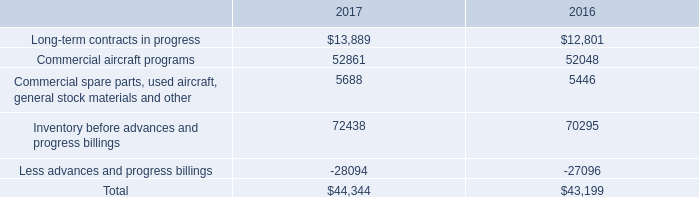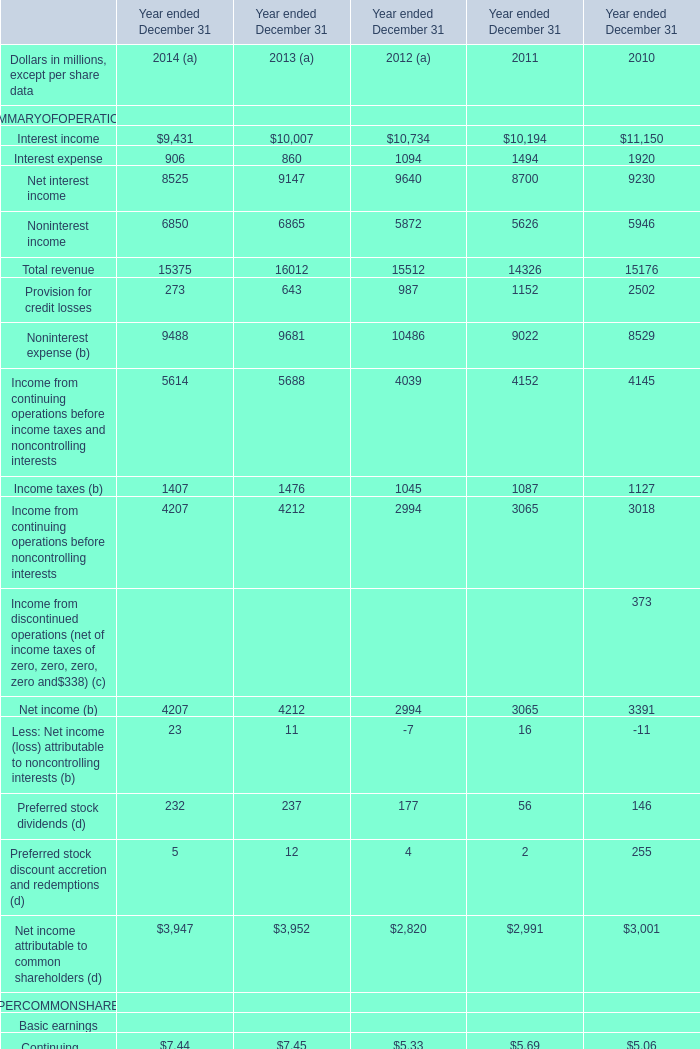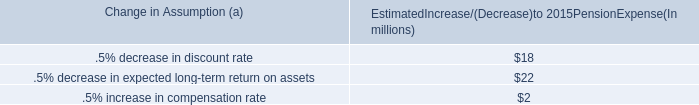Which element occupies the greatest proportion in total amount 2014? 
Answer: Total revenue. 